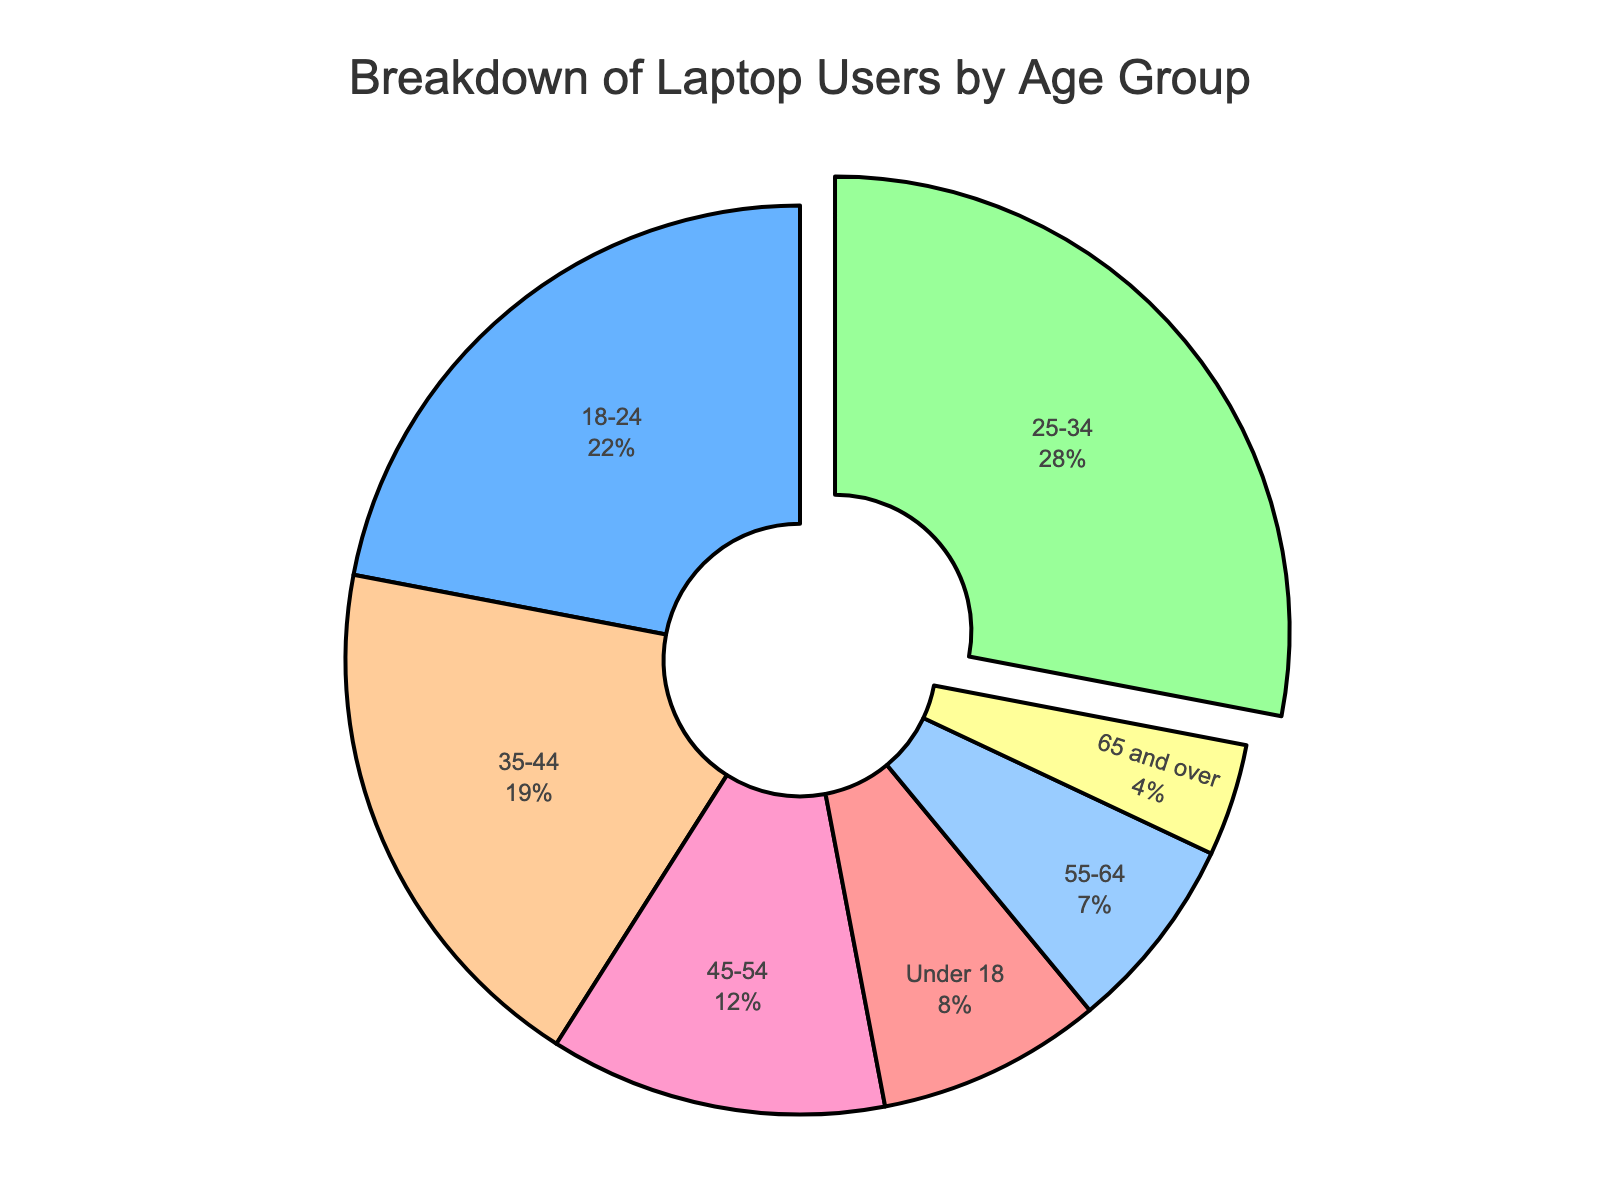Which age group has the highest percentage of laptop users? The figure highlights the wedge corresponding to the highest percentage. The largest segment, which is slightly pulled out, is for the age group 25-34.
Answer: 25-34 What is the combined percentage of laptop users for age groups under 18 and 65 and over? The percentage of users under 18 is 8%, and for those 65 and over is 4%. Adding these together gives 8% + 4%.
Answer: 12% Which age group has more laptop users, 35-44 or 45-54? Visually comparing the slices, the segment for the age group 35-44 is larger than that for 45-54. This corresponds to higher percentages for the former group.
Answer: 35-44 How much higher is the percentage of laptop users in the 25-34 age group compared to the 55-64 age group? The percentage for the 25-34 group is 28%, and for the 55-64 group, it is 7%. The difference is 28% - 7%.
Answer: 21% Which three age groups have the smallest percentages of laptop users, and what are their combined percentages? In descending order, the smallest percentages are for 65 and over (4%), 55-64 (7%), and under 18 (8%). Adding these gives 4% + 7% + 8%.
Answer: 19% What is the ratio of laptop users aged 18-24 to those aged 45-54? The percentage for 18-24 is 22%, and for 45-54, it is 12%. The ratio is 22/12, which simplifies to 11/6.
Answer: 11/6 or approximately 1.83 Compare the percentage of laptop users in the 25-34 age group to the combined percentage of users in the 55-64 and 65 and over age groups. The percentage for the 25-34 group is 28%. The combined percentage for 55-64 and 65 and over is 7% + 4%, which equals 11%.
Answer: 25-34 group is 17% higher What is the percentage difference between the age groups 35-44 and 55-64? The percentage for 35-44 is 19%, and for 55-64, it is 7%. The difference is 19% - 7%.
Answer: 12% What percentage of users are within the age groups spanning from 18 to 44 years? The combined percentages for the age groups 18-24 (22%), 25-34 (28%), and 35-44 (19%) are summed up as 22% + 28% + 19%.
Answer: 69% Which age group has the smallest percentage of laptop users, and what color is its segment on the pie chart? The age group 65 and over has the smallest percentage of laptop users at 4%. The color of this segment is yellow.
Answer: 65 and over, yellow 